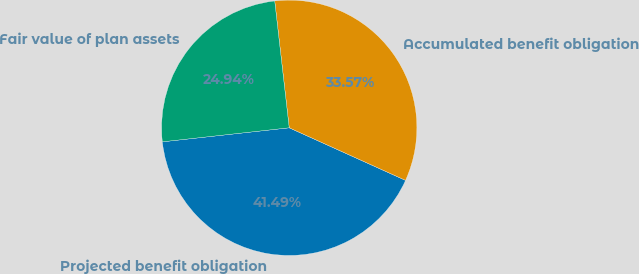Convert chart to OTSL. <chart><loc_0><loc_0><loc_500><loc_500><pie_chart><fcel>Projected benefit obligation<fcel>Accumulated benefit obligation<fcel>Fair value of plan assets<nl><fcel>41.49%<fcel>33.57%<fcel>24.94%<nl></chart> 